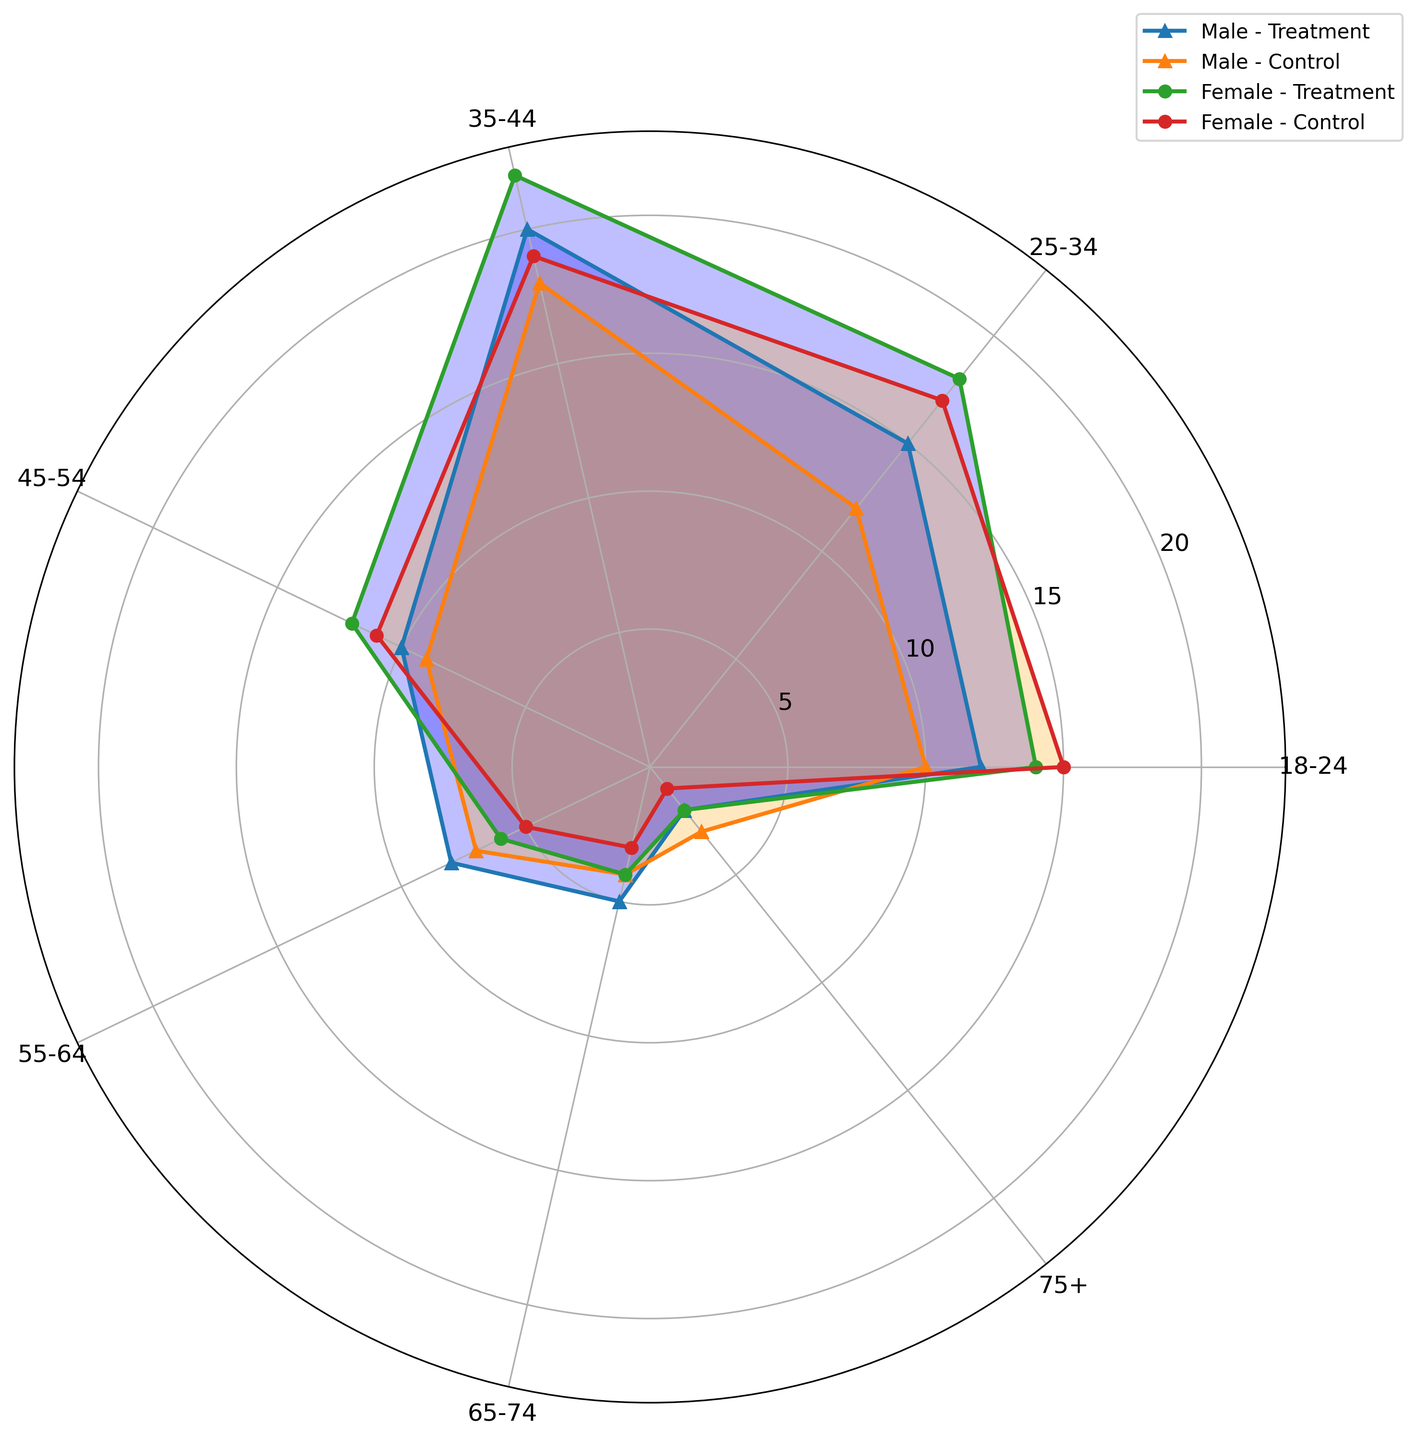Which age group of males has the highest number of participants in the Treatment arm? To find the highest number of male participants in the Treatment arm, look at the lengths of the blue segments marked with triangles within the Male-Treatment series. The longest segment corresponds to the 35-44 age group.
Answer: 35-44 How does the count of Females in the 25-34 age group compare between the Treatment and Control arms? To compare the count of Females in the 25-34 age group between Treatment and Control arms, identify the orange and blue regions with circle markers at the 25-34 label. The blue (Treatment) segment extends further than the orange (Control) segment, indicating there are more participants in Treatment.
Answer: More in Treatment Which gender and treatment arm combination has the lowest count in the 75+ age group? For the 75+ age group, examine the ends of the segments at the last label in each series. Both male and female segments are shortest in the Female-Control combination.
Answer: Female-Control What is the combined total number of participants in the 55-64 age group across both genders and treatment arms? Sum the lengths of all segments at the 55-64 label. Male-Treatment and Male-Control are 8 and 7, Female-Treatment and Female-Control are 6 and 5. Adding these gives 8 + 7 + 6 + 5 = 26.
Answer: 26 Which age group shows the largest difference in number of participants between Males and Females in the Control arm? To find the largest difference, review the lengths of the orange segments for Males and Females at each age group. The 18-24 group shows the largest difference, with Female-Control visibly longer than Male-Control.
Answer: 18-24 How many more 35-44 year old Females are there in the Treatment arm compared to the Control arm? Subtract the length of the Female-Control segment from the Female-Treatment segment at the 35-44 label. Sizes are approximately 22 for Treatment and 19 for Control, so 22 - 19 = 3.
Answer: 3 Which age group in the Control arm has an equal number of Males and Females? Find age groups where orange segments for Males and Females are of equal length. In the 65-74 group, the segments for both Males and Females in the Control arm are the same length.
Answer: 65-74 